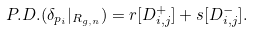Convert formula to latex. <formula><loc_0><loc_0><loc_500><loc_500>P . D . ( \delta _ { p _ { i } } | _ { R _ { g , n } } ) = r [ D _ { i , j } ^ { + } ] + s [ D _ { i , j } ^ { - } ] .</formula> 